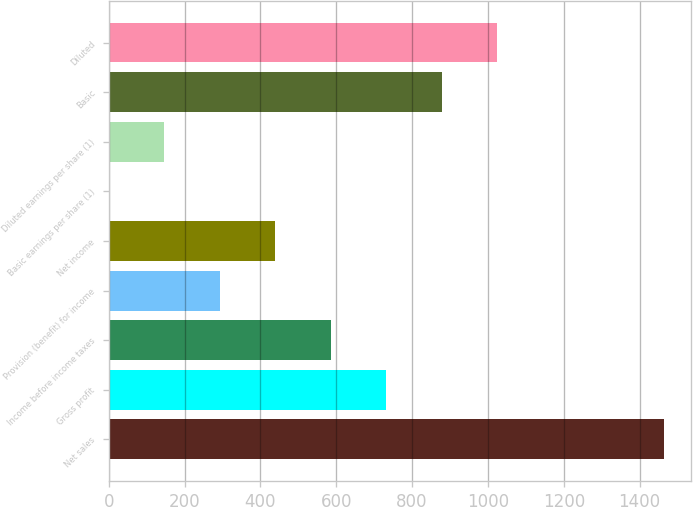Convert chart. <chart><loc_0><loc_0><loc_500><loc_500><bar_chart><fcel>Net sales<fcel>Gross profit<fcel>Income before income taxes<fcel>Provision (benefit) for income<fcel>Net income<fcel>Basic earnings per share (1)<fcel>Diluted earnings per share (1)<fcel>Basic<fcel>Diluted<nl><fcel>1463<fcel>731.58<fcel>585.29<fcel>292.71<fcel>439<fcel>0.13<fcel>146.42<fcel>877.87<fcel>1024.16<nl></chart> 